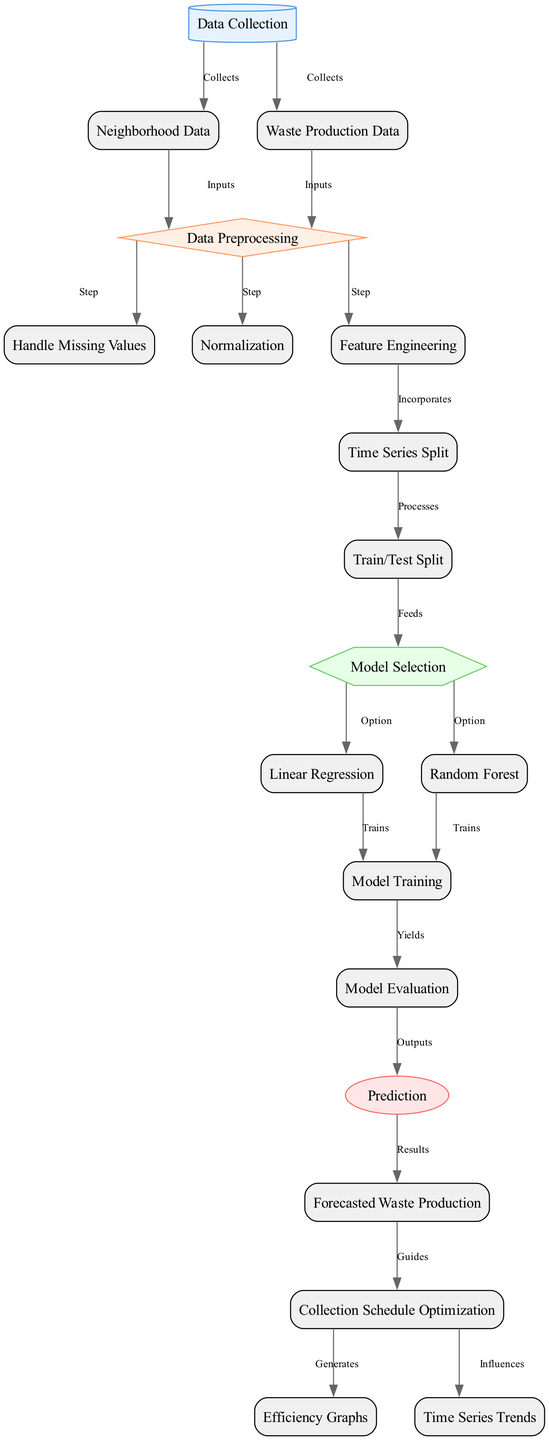What are the main categories of data collected? The diagram has two main categories of data collected, which are Neighborhood Data and Waste Production Data, both stemming from the Data Collection node.
Answer: Neighborhood Data, Waste Production Data How many main processing steps are there after data collection? After data collection, there are three main processing steps: Handle Missing Values, Normalization, and Feature Engineering.
Answer: Three Which node directly influences the Collection Schedule Optimization? The node Forecasted Waste Production feeds directly into Collection Schedule Optimization, guiding its process.
Answer: Forecasted Waste Production What are the two options for model selection? The model selection offers two options: Linear Regression and Random Forest, clearly indicated in the diagram.
Answer: Linear Regression, Random Forest Which node generates efficiency graphs? The Collection Schedule Optimization node generates Efficiency Graphs as part of its output.
Answer: Collection Schedule Optimization How does Feature Engineering relate to Time Series Split? Feature Engineering directly incorporates time series information to prepare data for analysis, leading into the Time Series Split stage.
Answer: Incorporates What node processes the data after time series split? After the Time Series Split, the data proceeds to the Train/Test Split stage for further processing and validation.
Answer: Train/Test Split How does the model evaluation node output its results? The Model Evaluation node produces outputs that specifically lead into the Prediction node, showcasing its findings for future predictions.
Answer: Prediction What guides the schedule optimization process? The guidance for Schedule Optimization comes from the Forecasted Waste Production, utilized to enhance scheduling effectiveness.
Answer: Forecasted Waste Production 